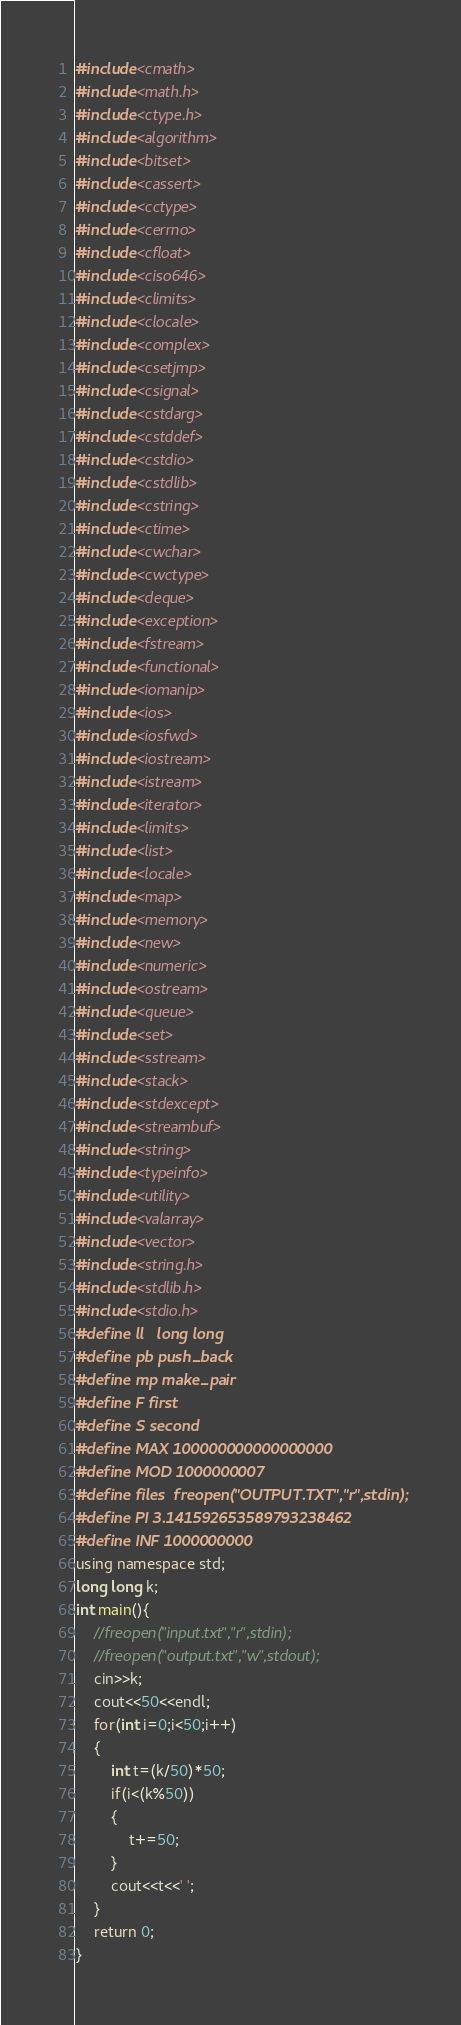Convert code to text. <code><loc_0><loc_0><loc_500><loc_500><_C++_>#include<cmath>
#include<math.h>
#include<ctype.h>
#include<algorithm>
#include<bitset>
#include<cassert>
#include<cctype>
#include<cerrno>
#include<cfloat>
#include<ciso646>
#include<climits>
#include<clocale>
#include<complex>
#include<csetjmp>
#include<csignal>
#include<cstdarg>
#include<cstddef>
#include<cstdio>
#include<cstdlib>
#include<cstring>
#include<ctime>
#include<cwchar>
#include<cwctype>
#include<deque>
#include<exception>
#include<fstream>
#include<functional>
#include<iomanip>
#include<ios>
#include<iosfwd>
#include<iostream>
#include<istream>
#include<iterator>
#include<limits>
#include<list>
#include<locale>
#include<map>
#include<memory>
#include<new>
#include<numeric>
#include<ostream>
#include<queue>
#include<set>
#include<sstream>
#include<stack>
#include<stdexcept>
#include<streambuf>
#include<string>
#include<typeinfo>
#include<utility>
#include<valarray>
#include<vector>
#include<string.h>
#include<stdlib.h>
#include<stdio.h>
#define ll   long long
#define pb push_back
#define mp make_pair
#define F first
#define S second
#define MAX 100000000000000000
#define MOD 1000000007
#define files  freopen("OUTPUT.TXT","r",stdin);
#define PI 3.141592653589793238462
#define INF 1000000000
using namespace std;
long long k;
int main(){
	//freopen("input.txt","r",stdin);
	//freopen("output.txt","w",stdout);
	cin>>k;
	cout<<50<<endl;
    for(int i=0;i<50;i++)
    {
    	int t=(k/50)*50;
    	if(i<(k%50))
    	{
    		t+=50;
		}
    	cout<<t<<' ';
	}
	return 0;
}</code> 